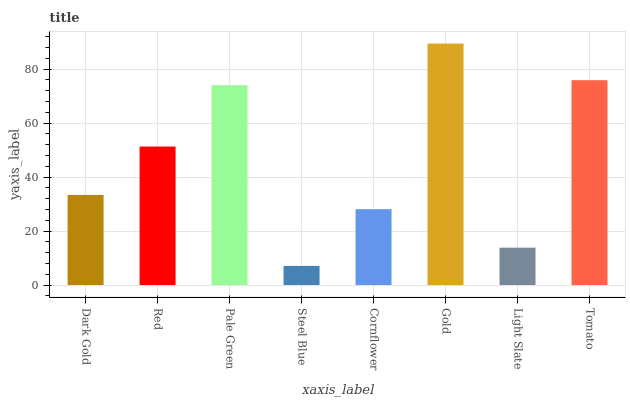Is Steel Blue the minimum?
Answer yes or no. Yes. Is Gold the maximum?
Answer yes or no. Yes. Is Red the minimum?
Answer yes or no. No. Is Red the maximum?
Answer yes or no. No. Is Red greater than Dark Gold?
Answer yes or no. Yes. Is Dark Gold less than Red?
Answer yes or no. Yes. Is Dark Gold greater than Red?
Answer yes or no. No. Is Red less than Dark Gold?
Answer yes or no. No. Is Red the high median?
Answer yes or no. Yes. Is Dark Gold the low median?
Answer yes or no. Yes. Is Dark Gold the high median?
Answer yes or no. No. Is Pale Green the low median?
Answer yes or no. No. 